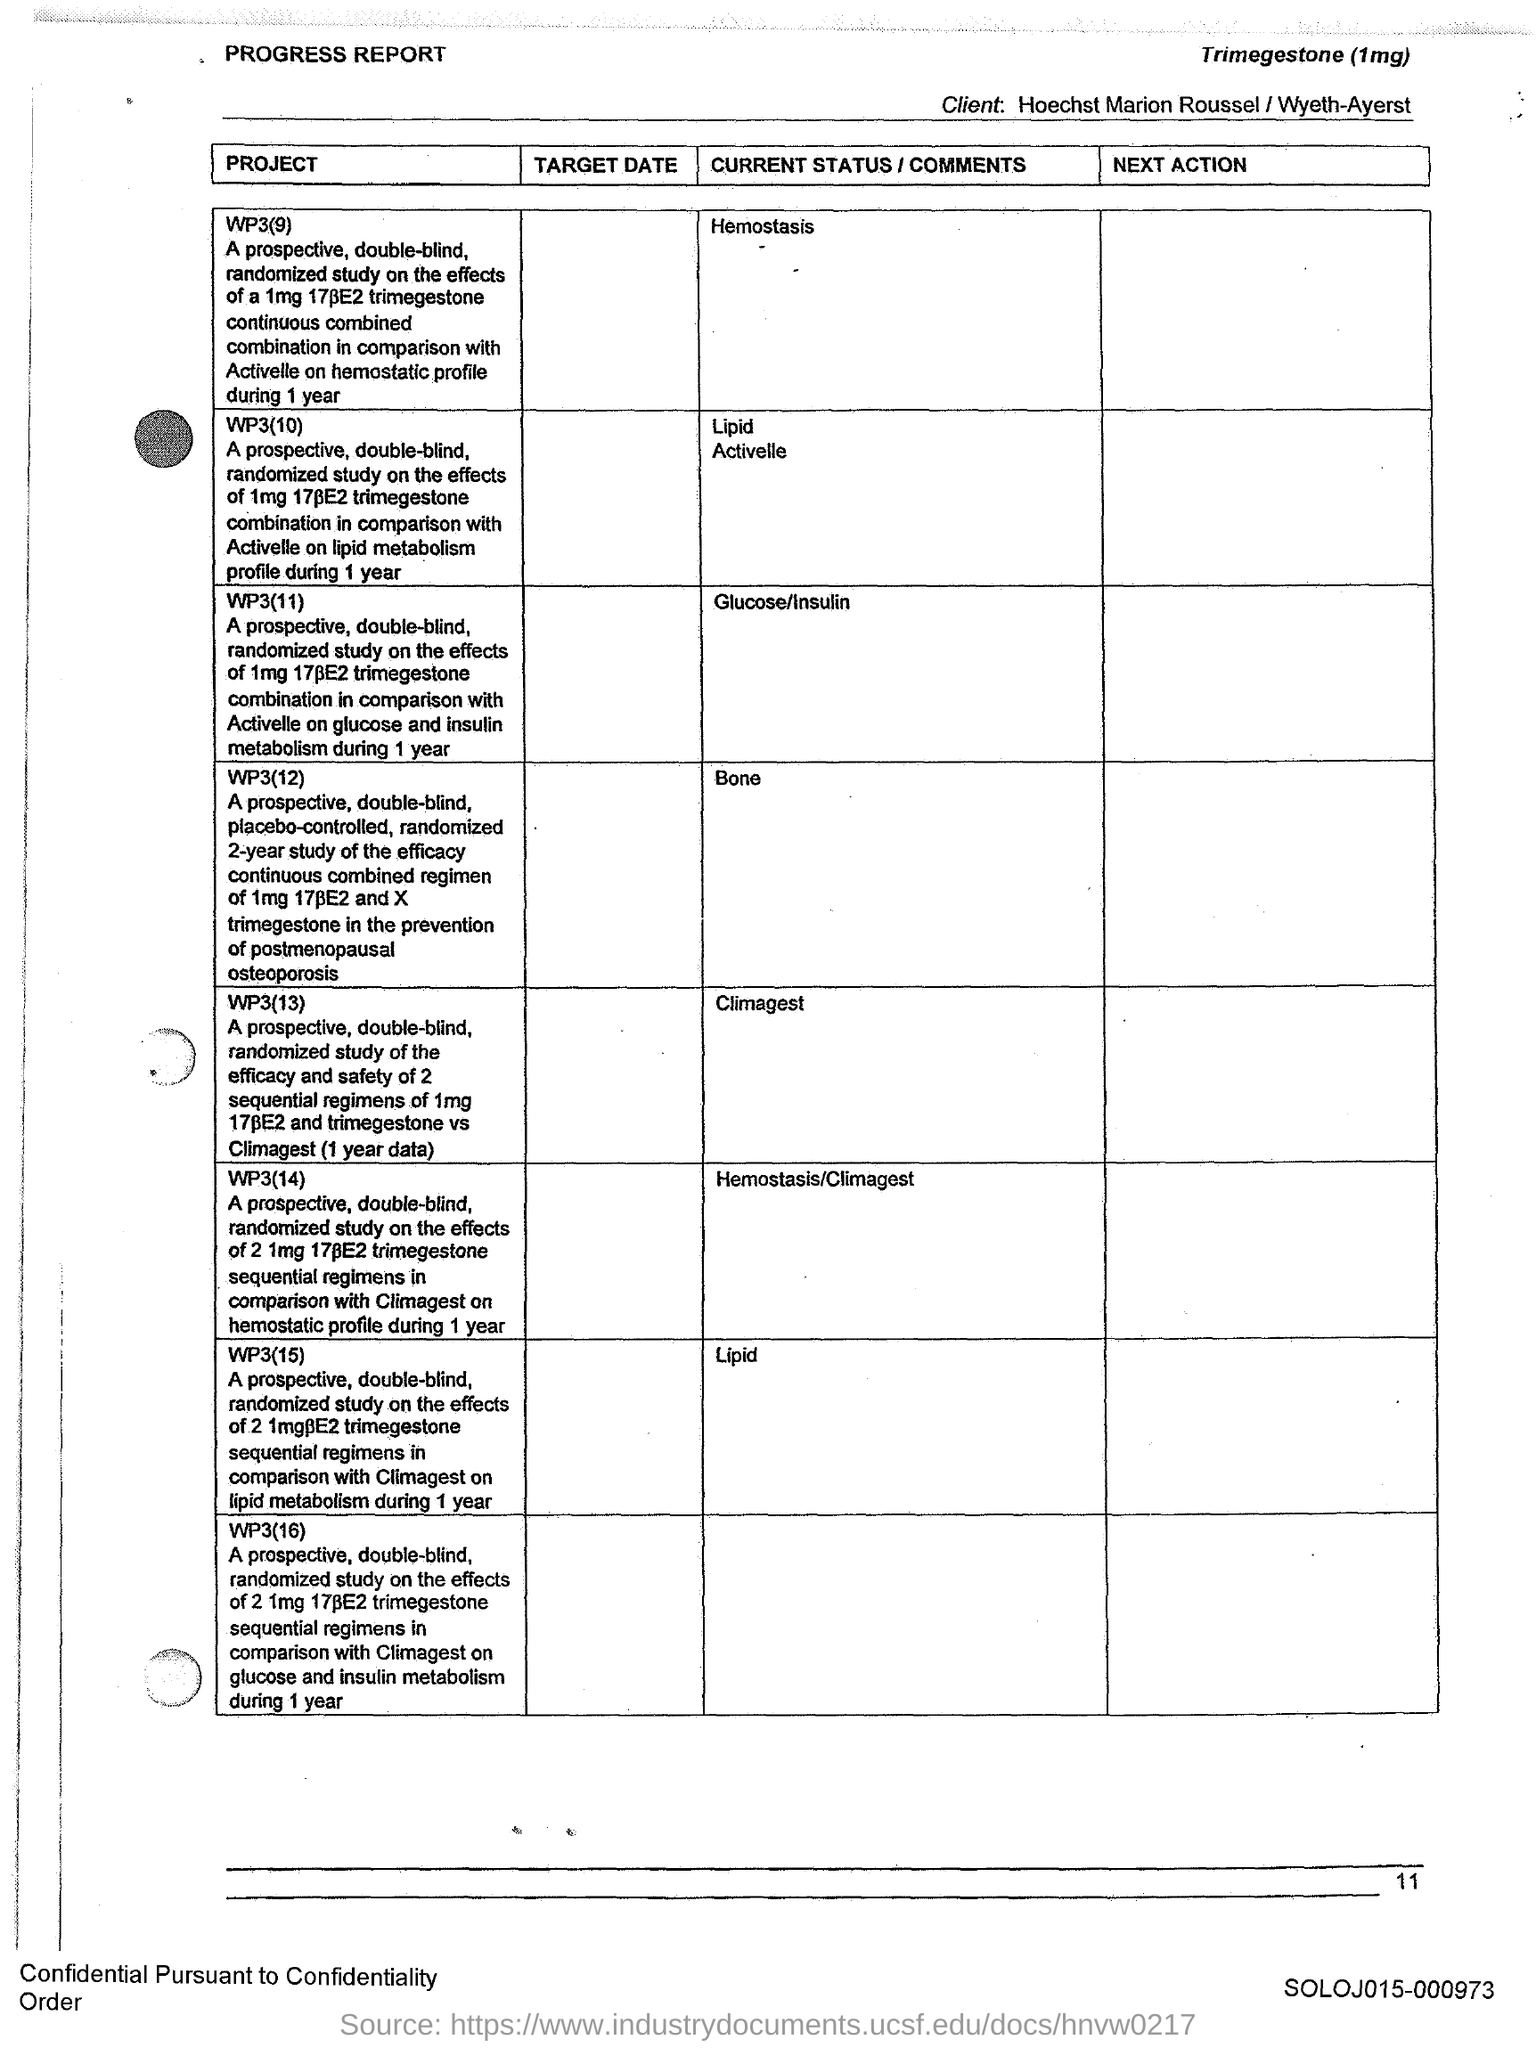Draw attention to some important aspects in this diagram. The current status of project WP3(12) is unknown. The current status of project WP3(9), which focuses on hemostasis, is [insert update or explanation here]. The current status of the project WP3(13) is unknown, as it is not specified in the provided information. The page number is 11. The current status of project WP3(11) is to investigate the relationship between glucose and insulin in the context of the project. 